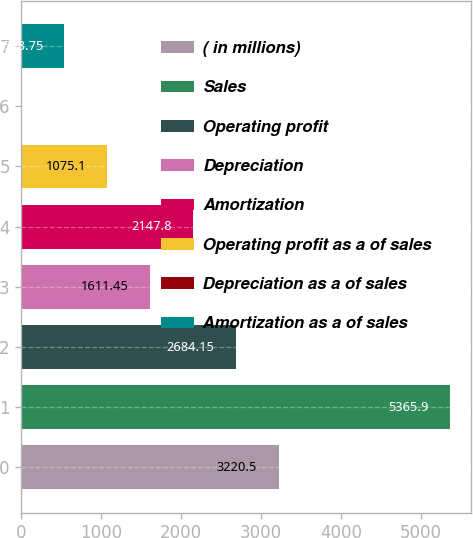<chart> <loc_0><loc_0><loc_500><loc_500><bar_chart><fcel>( in millions)<fcel>Sales<fcel>Operating profit<fcel>Depreciation<fcel>Amortization<fcel>Operating profit as a of sales<fcel>Depreciation as a of sales<fcel>Amortization as a of sales<nl><fcel>3220.5<fcel>5365.9<fcel>2684.15<fcel>1611.45<fcel>2147.8<fcel>1075.1<fcel>2.4<fcel>538.75<nl></chart> 